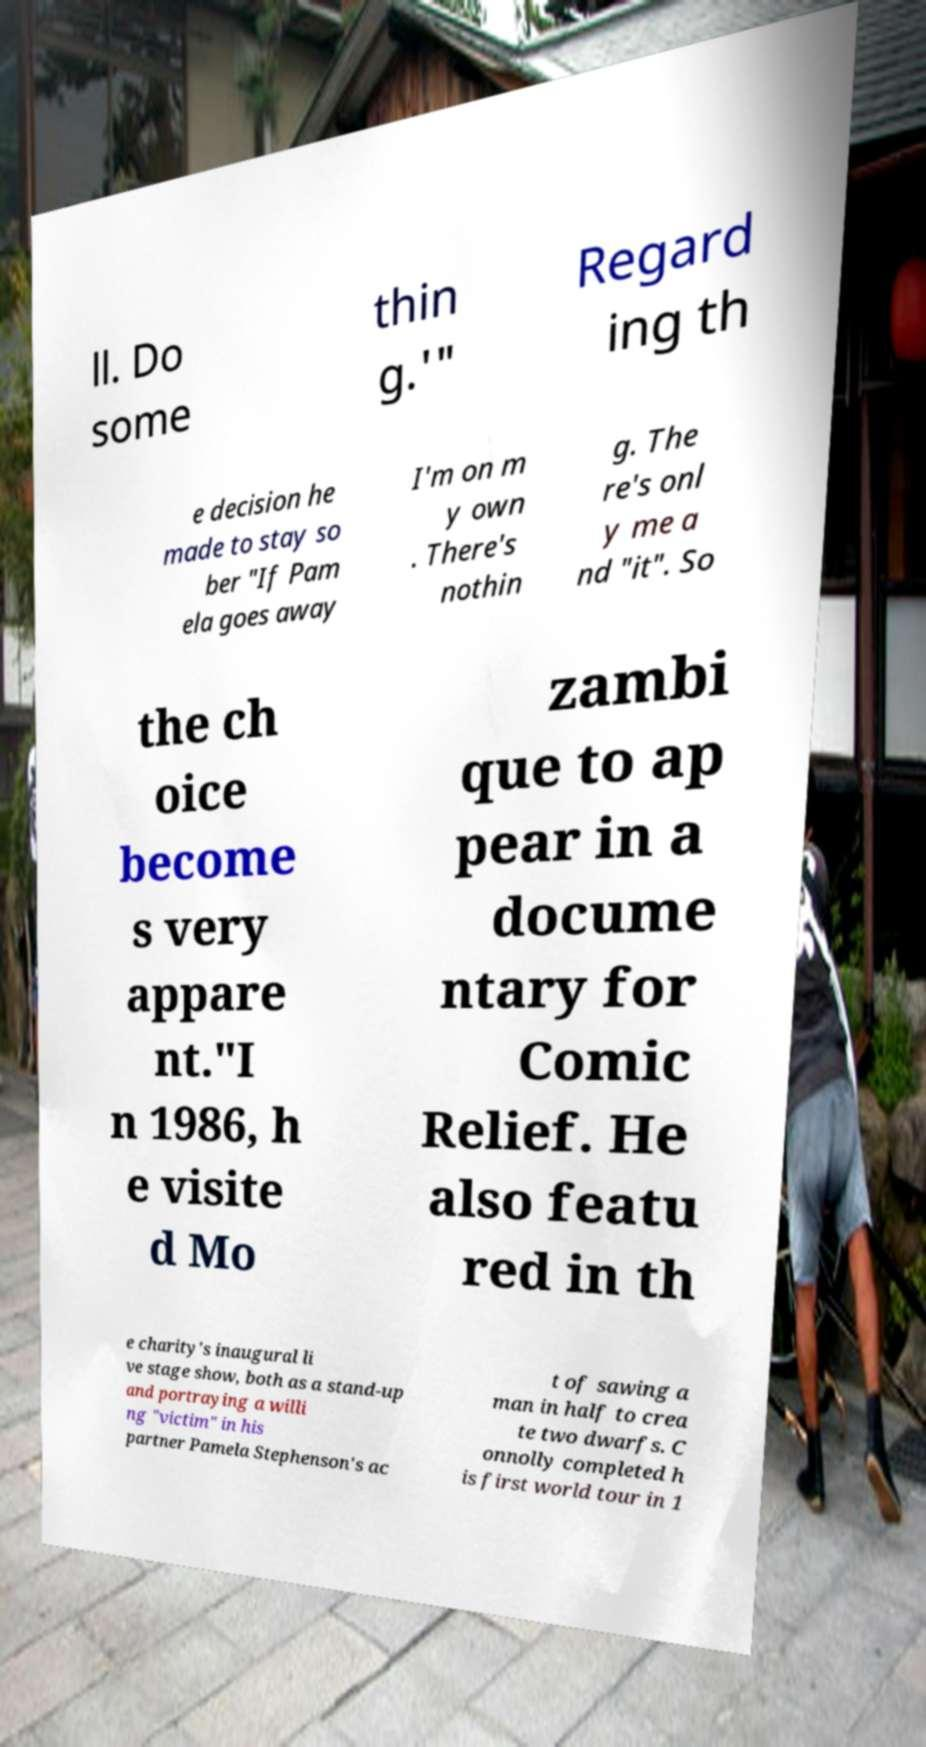Can you read and provide the text displayed in the image?This photo seems to have some interesting text. Can you extract and type it out for me? ll. Do some thin g.'" Regard ing th e decision he made to stay so ber "If Pam ela goes away I'm on m y own . There's nothin g. The re's onl y me a nd "it". So the ch oice become s very appare nt."I n 1986, h e visite d Mo zambi que to ap pear in a docume ntary for Comic Relief. He also featu red in th e charity's inaugural li ve stage show, both as a stand-up and portraying a willi ng "victim" in his partner Pamela Stephenson's ac t of sawing a man in half to crea te two dwarfs. C onnolly completed h is first world tour in 1 